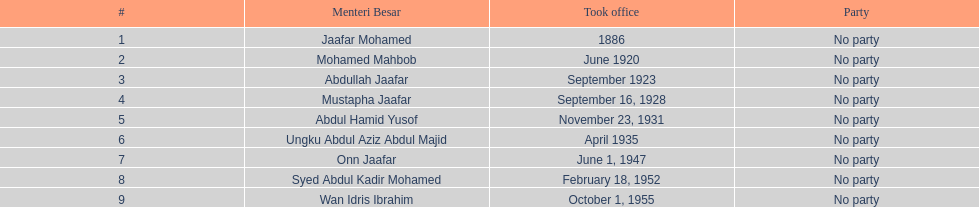Who is another person with the same last name as abdullah jaafar, not counting him? Mustapha Jaafar. 